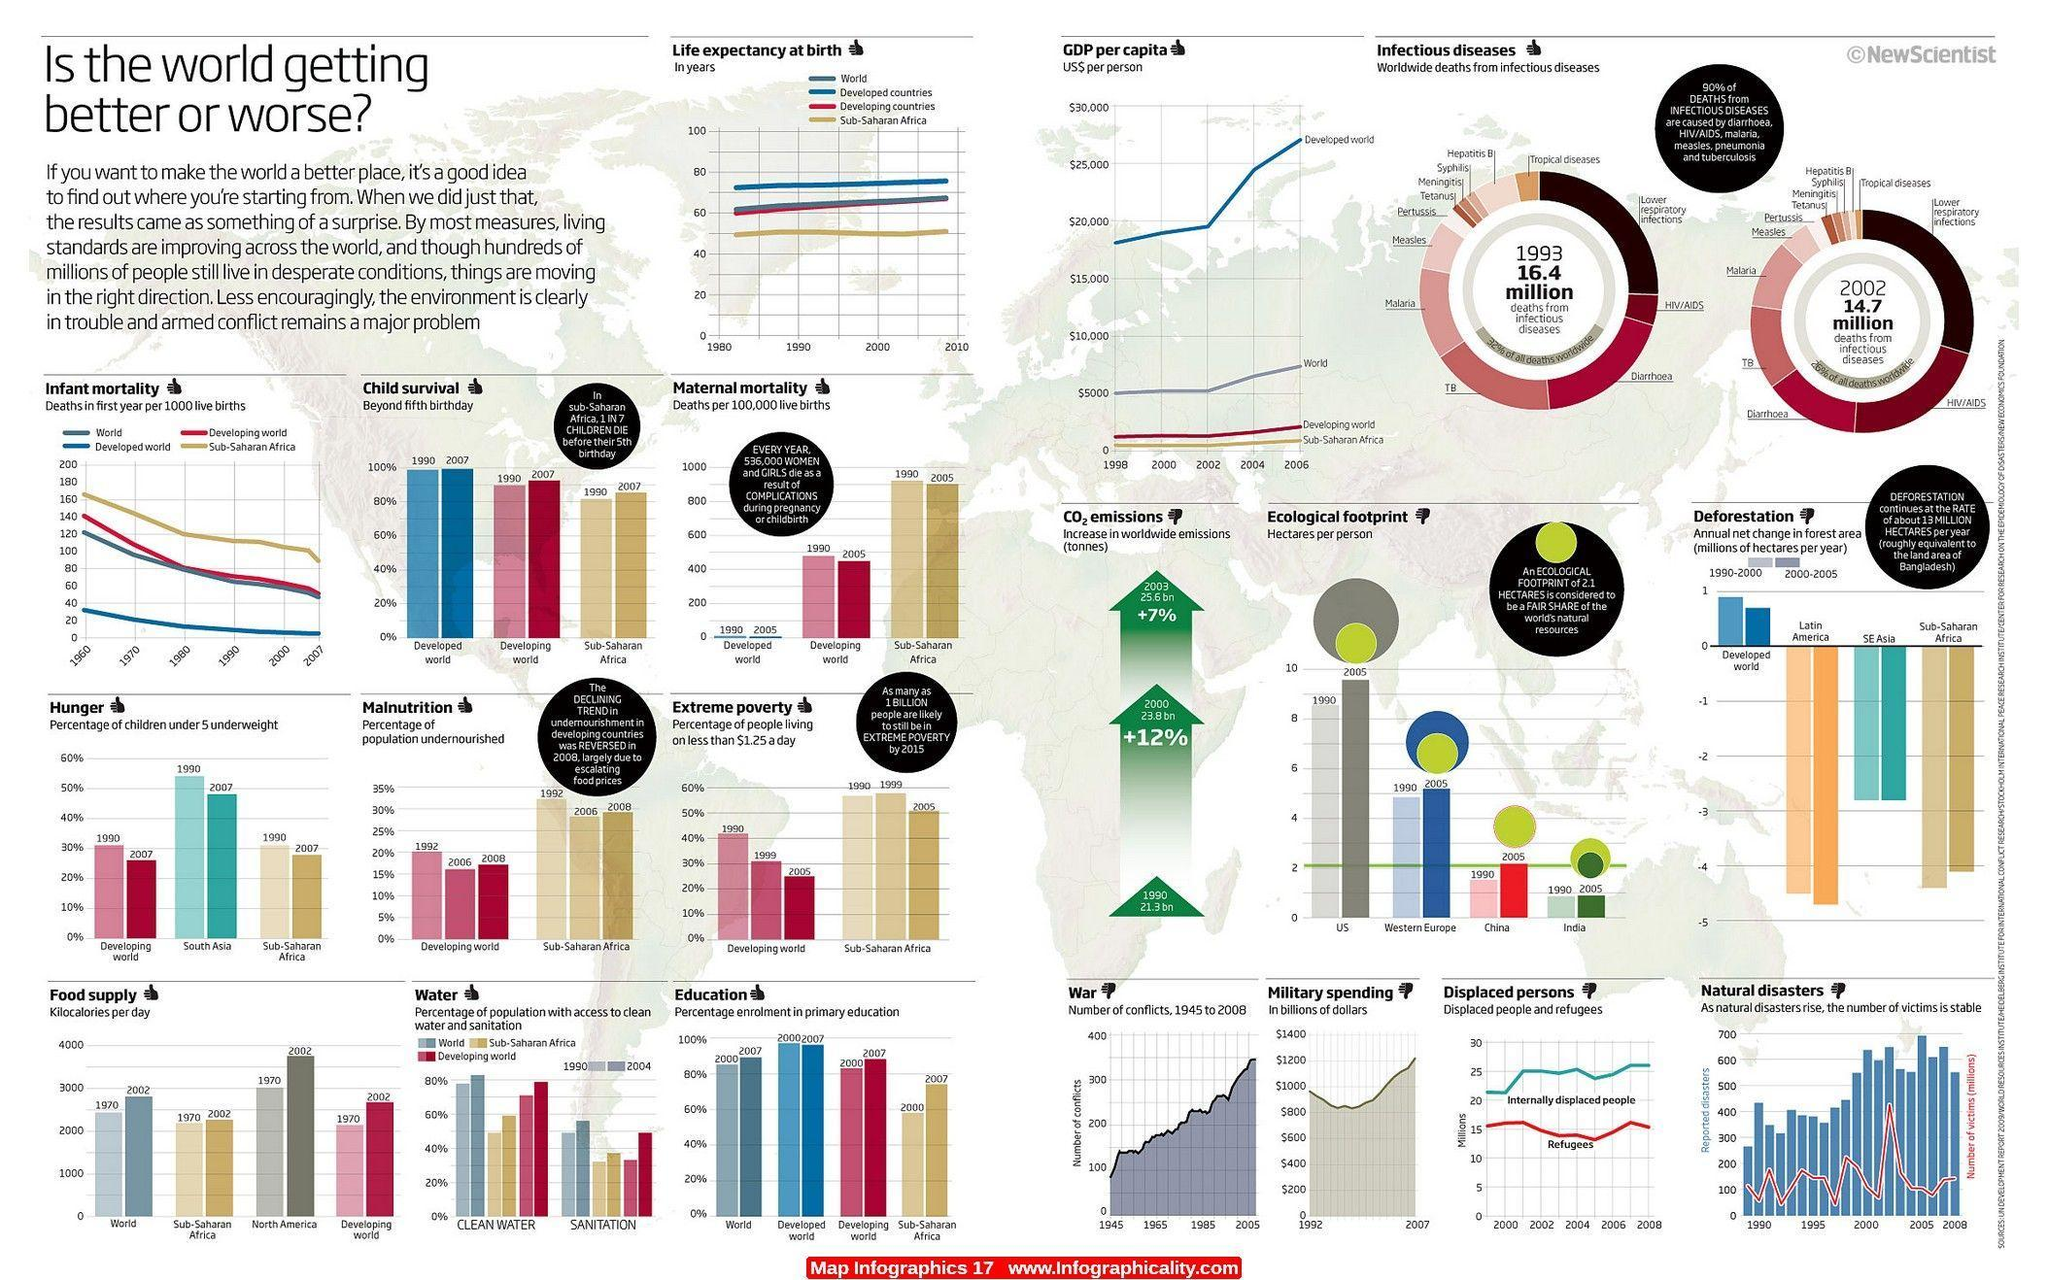In the education graph which group shows a slight decrease in percentage between the years 2000-2007 ?
Answer the question with a short phrase. Developed world In the education graph which group shows highest increase in percentage between the years 2000-2007 ? Sub-Saharan Africa Which year shows higher number of deaths due to HIV/AIDS? 2002 In the food supply graph, which group shows lowest increase from 1970-2002? Sub-Saharan Africa By what percentage has CO2 emissions increased from 2000 to 2003? +7% What is the main reason for increase in malnutrition percentage from 2006 to 2008? escalating food prices In the GDP per capita graph, which group shows highest increase from 2002-2006? Developed world In which year's graph is the number of deaths due to TB higher? 1993 In the graph, which year shows higher number of deaths due to infectious diseases? 1993 In the graph depicting war, what is the approximate number of conflicts in 2005 350 